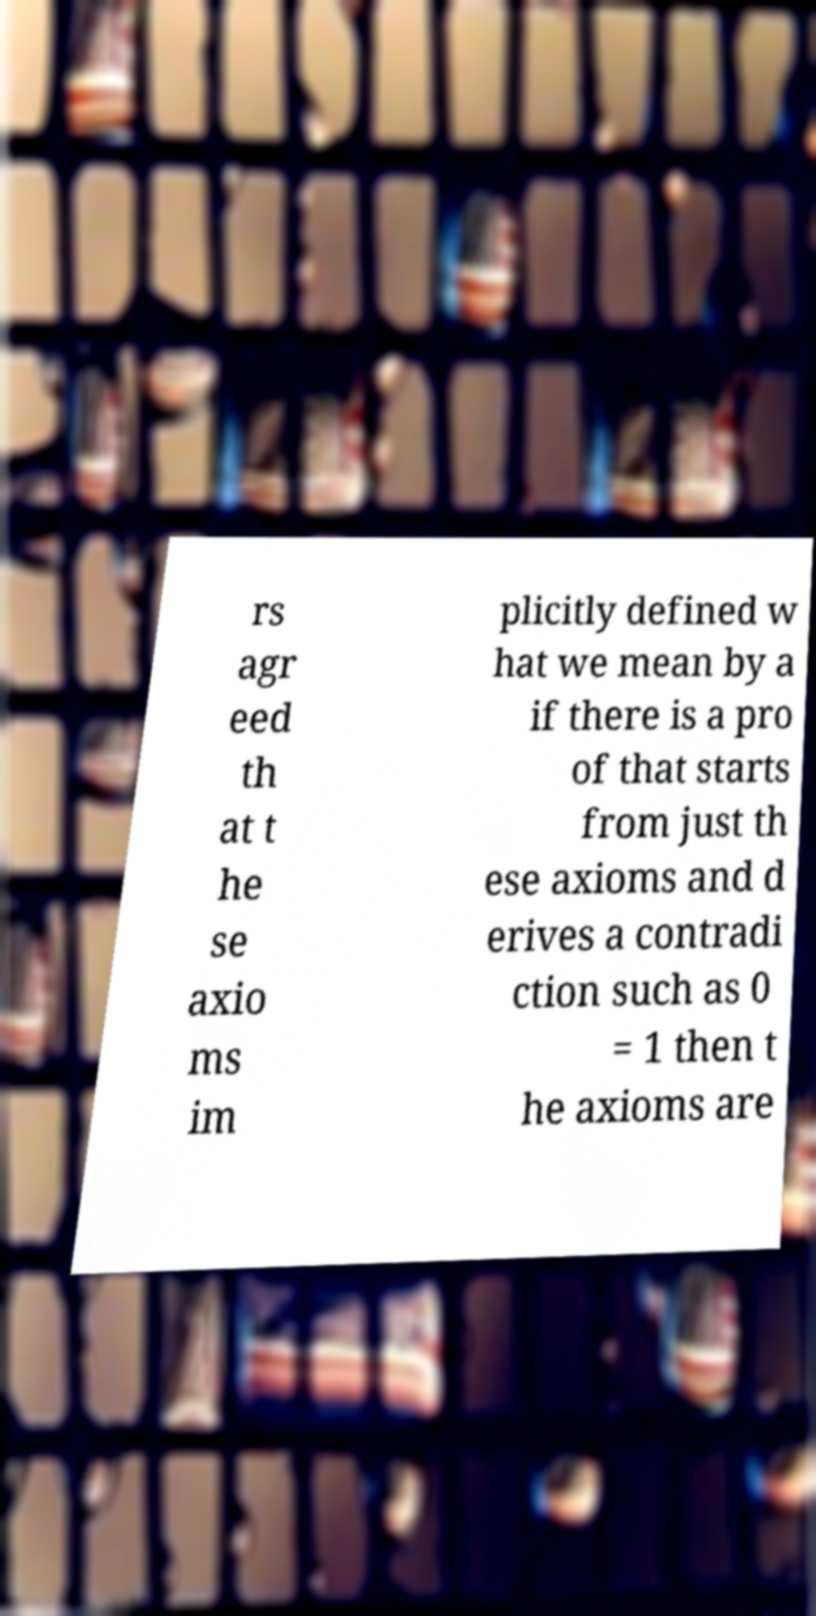For documentation purposes, I need the text within this image transcribed. Could you provide that? rs agr eed th at t he se axio ms im plicitly defined w hat we mean by a if there is a pro of that starts from just th ese axioms and d erives a contradi ction such as 0 = 1 then t he axioms are 